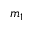<formula> <loc_0><loc_0><loc_500><loc_500>m _ { 1 }</formula> 